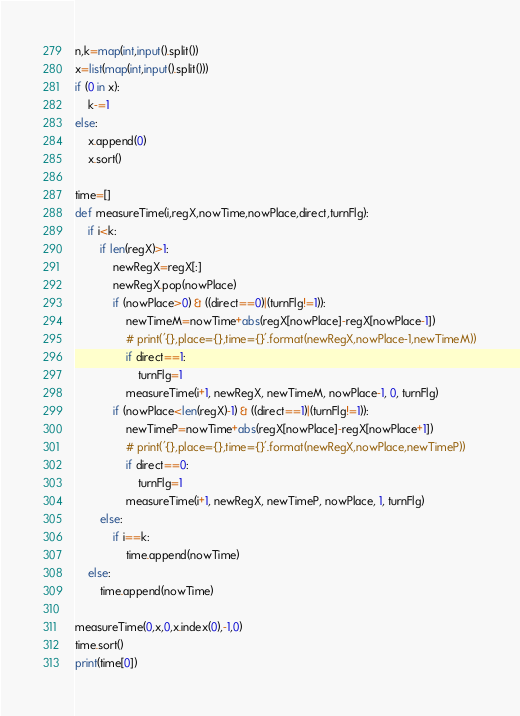Convert code to text. <code><loc_0><loc_0><loc_500><loc_500><_Python_>n,k=map(int,input().split())
x=list(map(int,input().split()))
if (0 in x):
    k-=1
else:
    x.append(0)
    x.sort()

time=[]
def measureTime(i,regX,nowTime,nowPlace,direct,turnFlg):
    if i<k:
        if len(regX)>1:
            newRegX=regX[:]
            newRegX.pop(nowPlace)
            if (nowPlace>0) & ((direct==0)|(turnFlg!=1)):
                newTimeM=nowTime+abs(regX[nowPlace]-regX[nowPlace-1])
                # print('{},place={},time={}'.format(newRegX,nowPlace-1,newTimeM))
                if direct==1:
                    turnFlg=1
                measureTime(i+1, newRegX, newTimeM, nowPlace-1, 0, turnFlg)
            if (nowPlace<len(regX)-1) & ((direct==1)|(turnFlg!=1)):
                newTimeP=nowTime+abs(regX[nowPlace]-regX[nowPlace+1])
                # print('{},place={},time={}'.format(newRegX,nowPlace,newTimeP))
                if direct==0:
                    turnFlg=1
                measureTime(i+1, newRegX, newTimeP, nowPlace, 1, turnFlg)
        else:
            if i==k:
                time.append(nowTime)
    else:
        time.append(nowTime)

measureTime(0,x,0,x.index(0),-1,0)
time.sort()
print(time[0])
</code> 